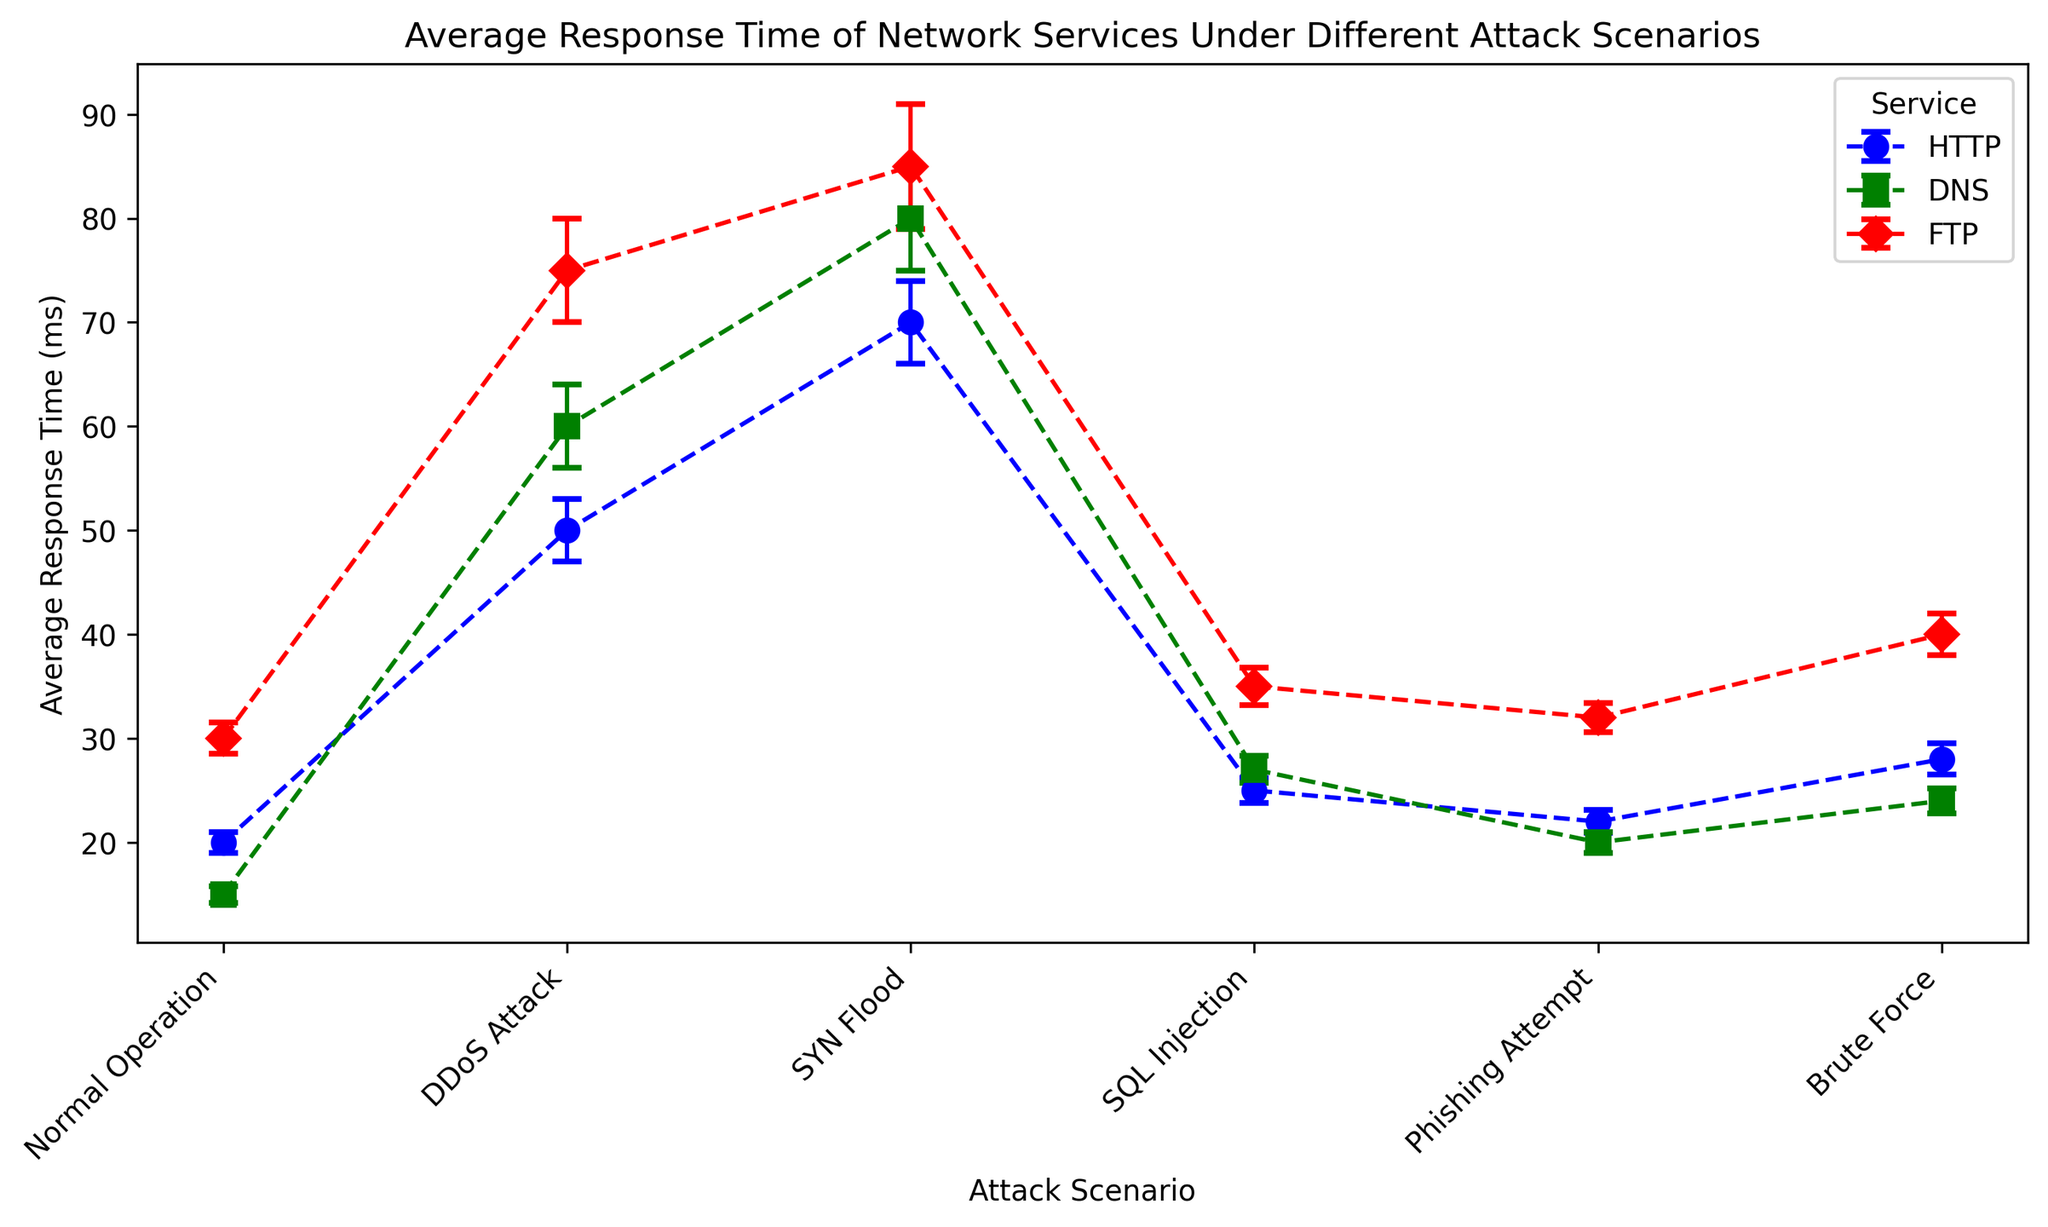What is the average response time for HTTP service under DDoS Attack compared to SYN Flood? The chart shows the average response time of HTTP service under DDoS Attack is 50 ms, and under SYN Flood, it is 70 ms. By comparing these two values: 50 ms < 70 ms.
Answer: 50 ms Under which attack scenario, does DNS service have the highest average response time? Observing the DNS average response times across all scenarios, the highest value is 80 ms under the SYN Flood scenario.
Answer: SYN Flood What is the difference in average response time of FTP service between Normal Operation and SQL Injection? From the figure, the average response time of FTP under Normal Operation is 30 ms, and 35 ms under SQL Injection. The difference is 35 ms - 30 ms = 5 ms.
Answer: 5 ms Which service has the smallest average response time under Phishing Attempt? The smallest average response time under Phishing Attempt can be observed: HTTP (22 ms), DNS (20 ms), FTP (32 ms). DNS has the smallest value of 20 ms.
Answer: DNS How does the average response time of DNS service under DDoS Attack compare with normal operation? Comparing the average response times of DNS: under normal operation, it is 15 ms; under DDoS Attack, it is 60 ms. Therefore, 60 ms is significantly greater than 15 ms.
Answer: Greater What feature makes the FTP services visually distinct in the plot? The markers representing FTP services in the plot are distinctively red diamonds, making them visually distinguishable from HTTP and DNS.
Answer: Red diamonds How does the standard error for HTTP service under Normal Operation compare to DDoS Attack? The standard error for HTTP service under Normal Operation is 1 ms, and under DDoS Attack, it is 3 ms. This shows the error is larger under DDoS Attack.
Answer: Larger For which attack scenario is the average response time of FTP services greater than all response times of HTTP services? Looking at the average response time of FTP services: 30 ms (Normal), 75 ms (DDoS), 85 ms (SYN Flood), 35 ms (SQL Injection), 32 ms (Phishing), 40 ms (Brute Force). Under SYN Flood at 85 ms, which is greater than all HTTP response times shown.
Answer: SYN Flood What is the combined average response time for DNS service during Phishing Attempt and Brute Force? From the figure, DNS response times are 20 ms (Phishing Attempt), 24 ms (Brute Force). Combined, this is 20 + 24 = 44 ms.
Answer: 44 ms Which service has the most consistent response time across all attack scenarios considering the standard errors? Evaluating the standard errors, DNS service shows relatively smaller errors (ranging from 0.8 to 5 ms), indicating more consistency across different scenarios.
Answer: DNS 